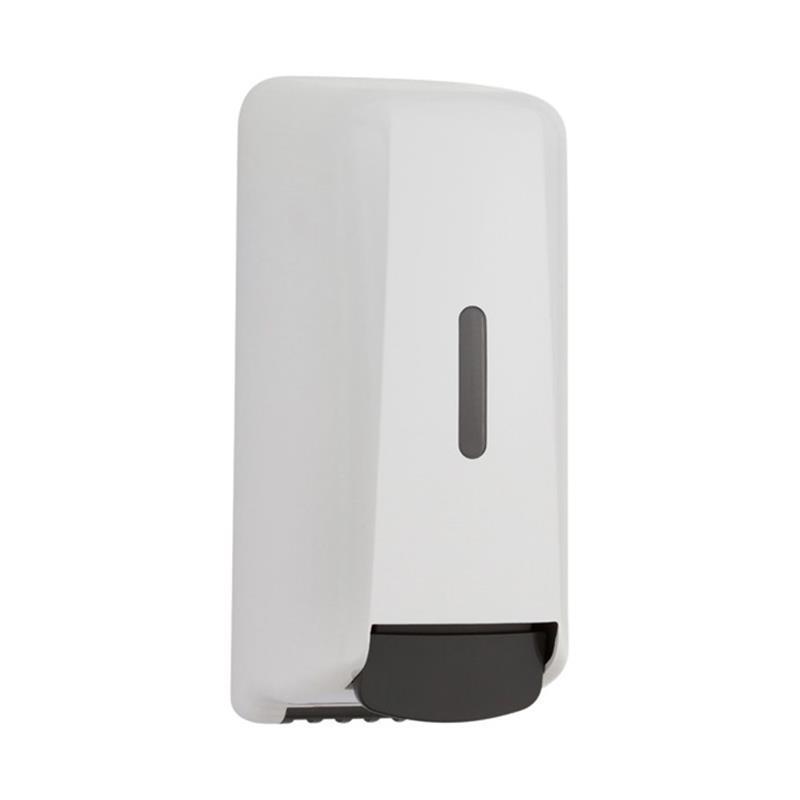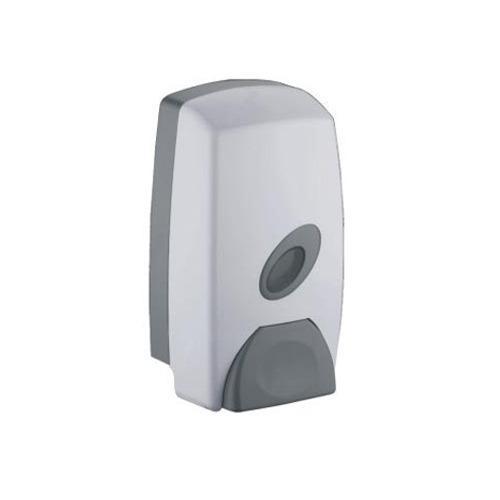The first image is the image on the left, the second image is the image on the right. For the images shown, is this caption "The dispenser in the image on the right has a gray button." true? Answer yes or no. Yes. The first image is the image on the left, the second image is the image on the right. Examine the images to the left and right. Is the description "the dispenser button in the image on the left is light gray" accurate? Answer yes or no. No. 